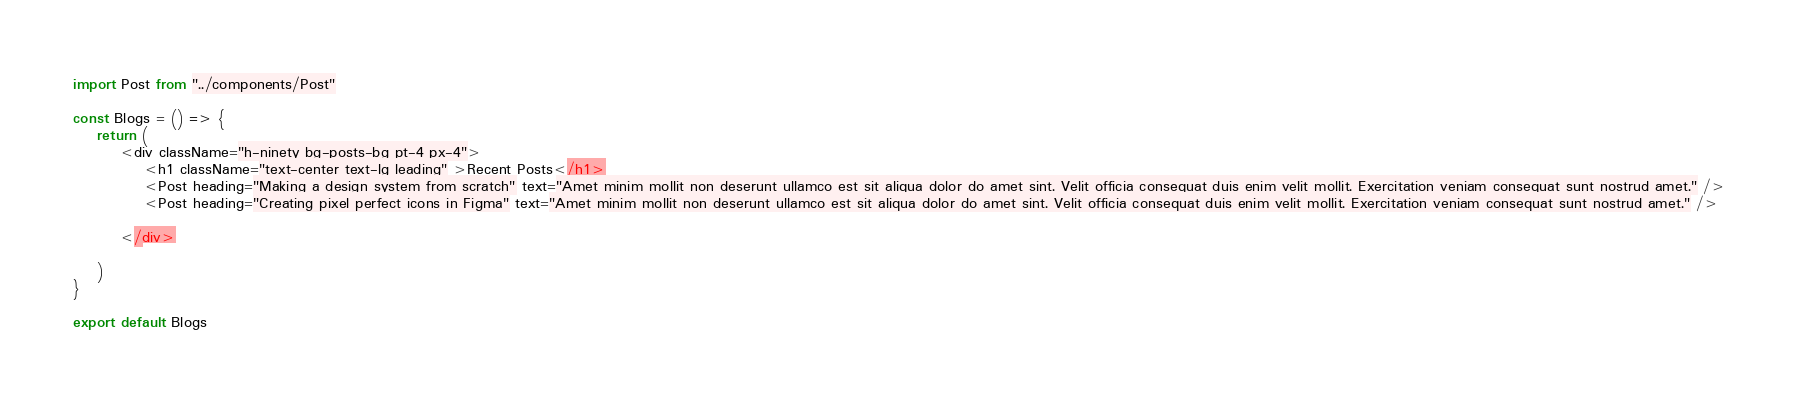<code> <loc_0><loc_0><loc_500><loc_500><_JavaScript_>import Post from "../components/Post"

const Blogs = () => {
    return (
        <div className="h-ninety bg-posts-bg pt-4 px-4">
            <h1 className="text-center text-lg leading" >Recent Posts</h1>
            <Post heading="Making a design system from scratch" text="Amet minim mollit non deserunt ullamco est sit aliqua dolor do amet sint. Velit officia consequat duis enim velit mollit. Exercitation veniam consequat sunt nostrud amet." />
            <Post heading="Creating pixel perfect icons in Figma" text="Amet minim mollit non deserunt ullamco est sit aliqua dolor do amet sint. Velit officia consequat duis enim velit mollit. Exercitation veniam consequat sunt nostrud amet." />

        </div>

    )
}

export default Blogs
</code> 